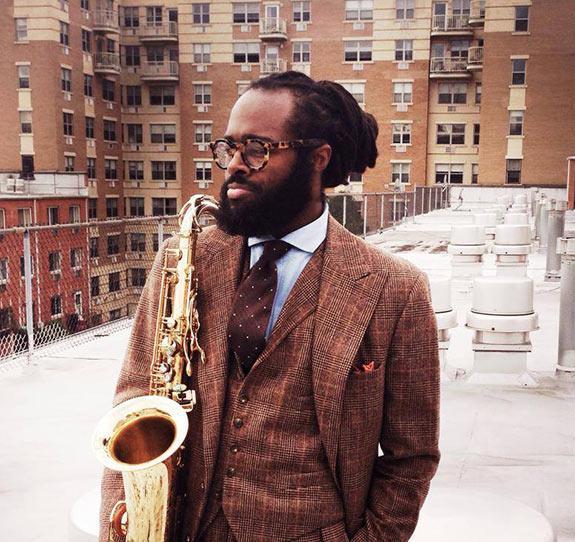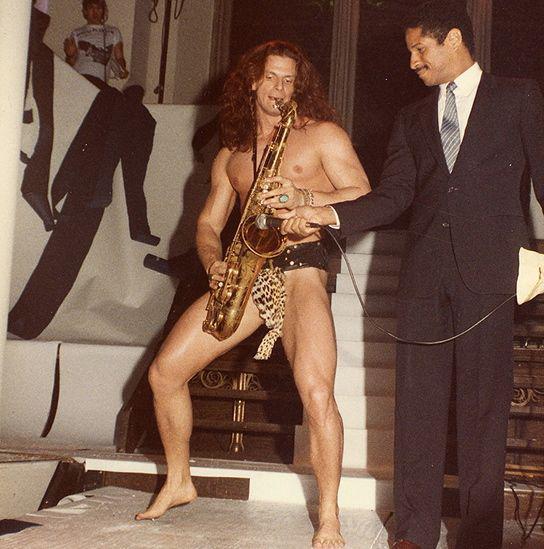The first image is the image on the left, the second image is the image on the right. For the images shown, is this caption "One image shows a saxophone held by a dark-skinned man in a suit, and the other image shows someone with long hair holding a saxophone in front of a flight of stairs." true? Answer yes or no. Yes. The first image is the image on the left, the second image is the image on the right. Considering the images on both sides, is "Every single person's elbow is clothed." valid? Answer yes or no. No. 